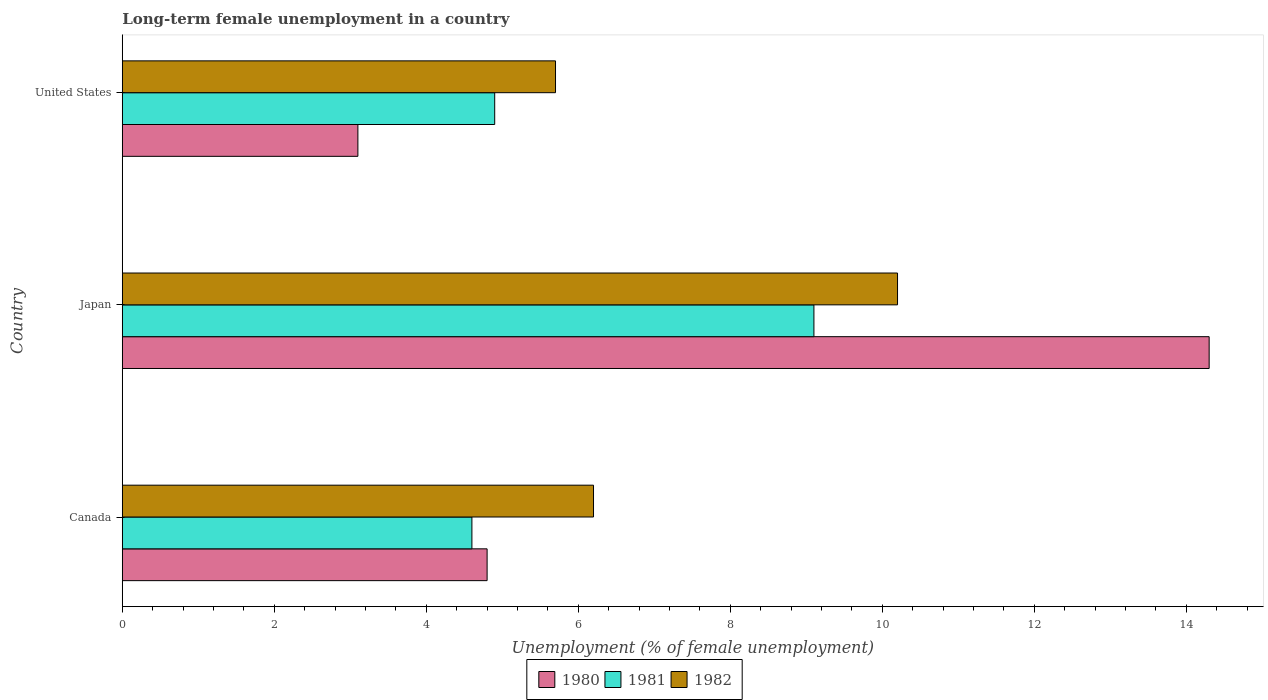How many groups of bars are there?
Make the answer very short. 3. How many bars are there on the 3rd tick from the bottom?
Provide a succinct answer. 3. What is the percentage of long-term unemployed female population in 1981 in Japan?
Your answer should be very brief. 9.1. Across all countries, what is the maximum percentage of long-term unemployed female population in 1980?
Ensure brevity in your answer.  14.3. Across all countries, what is the minimum percentage of long-term unemployed female population in 1982?
Give a very brief answer. 5.7. What is the total percentage of long-term unemployed female population in 1981 in the graph?
Ensure brevity in your answer.  18.6. What is the difference between the percentage of long-term unemployed female population in 1982 in Canada and that in Japan?
Provide a short and direct response. -4. What is the difference between the percentage of long-term unemployed female population in 1982 in Japan and the percentage of long-term unemployed female population in 1980 in United States?
Your response must be concise. 7.1. What is the average percentage of long-term unemployed female population in 1980 per country?
Give a very brief answer. 7.4. What is the difference between the percentage of long-term unemployed female population in 1980 and percentage of long-term unemployed female population in 1982 in Canada?
Ensure brevity in your answer.  -1.4. In how many countries, is the percentage of long-term unemployed female population in 1981 greater than 6 %?
Give a very brief answer. 1. What is the ratio of the percentage of long-term unemployed female population in 1981 in Japan to that in United States?
Offer a very short reply. 1.86. Is the difference between the percentage of long-term unemployed female population in 1980 in Canada and United States greater than the difference between the percentage of long-term unemployed female population in 1982 in Canada and United States?
Offer a very short reply. Yes. What is the difference between the highest and the second highest percentage of long-term unemployed female population in 1982?
Make the answer very short. 4. What is the difference between the highest and the lowest percentage of long-term unemployed female population in 1980?
Your response must be concise. 11.2. In how many countries, is the percentage of long-term unemployed female population in 1981 greater than the average percentage of long-term unemployed female population in 1981 taken over all countries?
Keep it short and to the point. 1. What does the 2nd bar from the top in United States represents?
Keep it short and to the point. 1981. Is it the case that in every country, the sum of the percentage of long-term unemployed female population in 1981 and percentage of long-term unemployed female population in 1980 is greater than the percentage of long-term unemployed female population in 1982?
Provide a short and direct response. Yes. How many bars are there?
Your response must be concise. 9. Are all the bars in the graph horizontal?
Offer a terse response. Yes. What is the difference between two consecutive major ticks on the X-axis?
Provide a succinct answer. 2. Does the graph contain any zero values?
Your answer should be compact. No. Does the graph contain grids?
Provide a short and direct response. No. How many legend labels are there?
Make the answer very short. 3. What is the title of the graph?
Ensure brevity in your answer.  Long-term female unemployment in a country. What is the label or title of the X-axis?
Keep it short and to the point. Unemployment (% of female unemployment). What is the label or title of the Y-axis?
Offer a very short reply. Country. What is the Unemployment (% of female unemployment) of 1980 in Canada?
Your response must be concise. 4.8. What is the Unemployment (% of female unemployment) of 1981 in Canada?
Make the answer very short. 4.6. What is the Unemployment (% of female unemployment) of 1982 in Canada?
Give a very brief answer. 6.2. What is the Unemployment (% of female unemployment) in 1980 in Japan?
Offer a terse response. 14.3. What is the Unemployment (% of female unemployment) in 1981 in Japan?
Provide a succinct answer. 9.1. What is the Unemployment (% of female unemployment) of 1982 in Japan?
Give a very brief answer. 10.2. What is the Unemployment (% of female unemployment) of 1980 in United States?
Give a very brief answer. 3.1. What is the Unemployment (% of female unemployment) of 1981 in United States?
Offer a very short reply. 4.9. What is the Unemployment (% of female unemployment) in 1982 in United States?
Keep it short and to the point. 5.7. Across all countries, what is the maximum Unemployment (% of female unemployment) of 1980?
Offer a very short reply. 14.3. Across all countries, what is the maximum Unemployment (% of female unemployment) in 1981?
Make the answer very short. 9.1. Across all countries, what is the maximum Unemployment (% of female unemployment) in 1982?
Your response must be concise. 10.2. Across all countries, what is the minimum Unemployment (% of female unemployment) in 1980?
Offer a terse response. 3.1. Across all countries, what is the minimum Unemployment (% of female unemployment) in 1981?
Keep it short and to the point. 4.6. Across all countries, what is the minimum Unemployment (% of female unemployment) of 1982?
Your answer should be compact. 5.7. What is the total Unemployment (% of female unemployment) in 1980 in the graph?
Give a very brief answer. 22.2. What is the total Unemployment (% of female unemployment) of 1982 in the graph?
Provide a short and direct response. 22.1. What is the difference between the Unemployment (% of female unemployment) in 1980 in Canada and that in Japan?
Offer a very short reply. -9.5. What is the difference between the Unemployment (% of female unemployment) in 1981 in Canada and that in Japan?
Offer a terse response. -4.5. What is the difference between the Unemployment (% of female unemployment) in 1980 in Canada and that in United States?
Keep it short and to the point. 1.7. What is the difference between the Unemployment (% of female unemployment) of 1981 in Japan and that in United States?
Give a very brief answer. 4.2. What is the difference between the Unemployment (% of female unemployment) of 1982 in Japan and that in United States?
Your answer should be very brief. 4.5. What is the difference between the Unemployment (% of female unemployment) in 1980 in Canada and the Unemployment (% of female unemployment) in 1981 in Japan?
Your answer should be very brief. -4.3. What is the difference between the Unemployment (% of female unemployment) in 1980 in Canada and the Unemployment (% of female unemployment) in 1981 in United States?
Make the answer very short. -0.1. What is the difference between the Unemployment (% of female unemployment) of 1980 in Japan and the Unemployment (% of female unemployment) of 1982 in United States?
Offer a terse response. 8.6. What is the average Unemployment (% of female unemployment) in 1980 per country?
Provide a succinct answer. 7.4. What is the average Unemployment (% of female unemployment) in 1981 per country?
Provide a succinct answer. 6.2. What is the average Unemployment (% of female unemployment) of 1982 per country?
Your answer should be compact. 7.37. What is the difference between the Unemployment (% of female unemployment) of 1980 and Unemployment (% of female unemployment) of 1981 in Canada?
Keep it short and to the point. 0.2. What is the difference between the Unemployment (% of female unemployment) in 1980 and Unemployment (% of female unemployment) in 1982 in Canada?
Offer a terse response. -1.4. What is the difference between the Unemployment (% of female unemployment) of 1980 and Unemployment (% of female unemployment) of 1981 in United States?
Offer a very short reply. -1.8. What is the difference between the Unemployment (% of female unemployment) in 1980 and Unemployment (% of female unemployment) in 1982 in United States?
Offer a terse response. -2.6. What is the ratio of the Unemployment (% of female unemployment) of 1980 in Canada to that in Japan?
Your answer should be very brief. 0.34. What is the ratio of the Unemployment (% of female unemployment) of 1981 in Canada to that in Japan?
Offer a very short reply. 0.51. What is the ratio of the Unemployment (% of female unemployment) of 1982 in Canada to that in Japan?
Your response must be concise. 0.61. What is the ratio of the Unemployment (% of female unemployment) in 1980 in Canada to that in United States?
Provide a short and direct response. 1.55. What is the ratio of the Unemployment (% of female unemployment) in 1981 in Canada to that in United States?
Provide a succinct answer. 0.94. What is the ratio of the Unemployment (% of female unemployment) of 1982 in Canada to that in United States?
Your answer should be compact. 1.09. What is the ratio of the Unemployment (% of female unemployment) of 1980 in Japan to that in United States?
Your response must be concise. 4.61. What is the ratio of the Unemployment (% of female unemployment) in 1981 in Japan to that in United States?
Give a very brief answer. 1.86. What is the ratio of the Unemployment (% of female unemployment) of 1982 in Japan to that in United States?
Your response must be concise. 1.79. What is the difference between the highest and the second highest Unemployment (% of female unemployment) of 1980?
Provide a succinct answer. 9.5. What is the difference between the highest and the second highest Unemployment (% of female unemployment) in 1982?
Your response must be concise. 4. What is the difference between the highest and the lowest Unemployment (% of female unemployment) in 1980?
Your answer should be very brief. 11.2. 